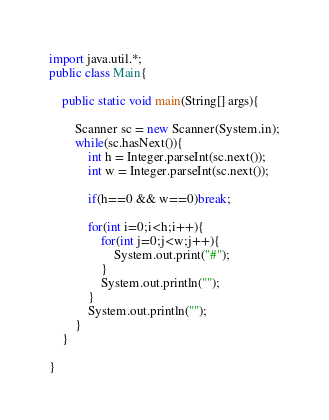Convert code to text. <code><loc_0><loc_0><loc_500><loc_500><_Java_>import java.util.*;
public class Main{

    public static void main(String[] args){

        Scanner sc = new Scanner(System.in);
        while(sc.hasNext()){
            int h = Integer.parseInt(sc.next());
            int w = Integer.parseInt(sc.next());
            
            if(h==0 && w==0)break;
            
            for(int i=0;i<h;i++){
                for(int j=0;j<w;j++){
                    System.out.print("#");
                }
                System.out.println("");
            }
            System.out.println("");
        }
    }

}

</code> 